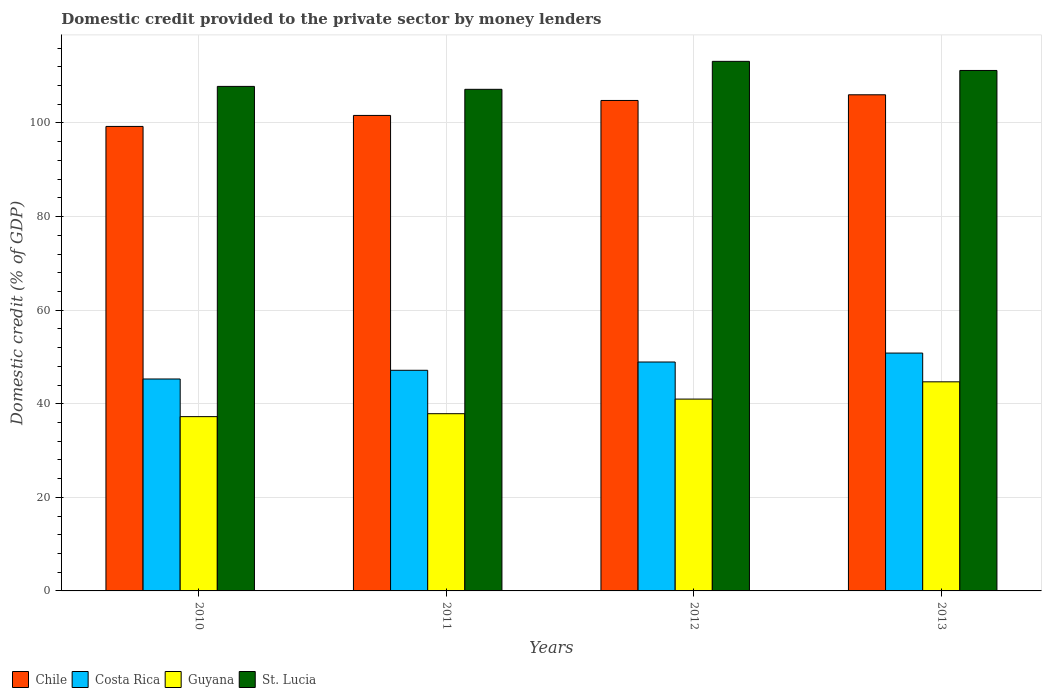How many different coloured bars are there?
Offer a very short reply. 4. How many groups of bars are there?
Ensure brevity in your answer.  4. Are the number of bars per tick equal to the number of legend labels?
Your answer should be very brief. Yes. How many bars are there on the 3rd tick from the right?
Provide a succinct answer. 4. What is the label of the 1st group of bars from the left?
Offer a terse response. 2010. What is the domestic credit provided to the private sector by money lenders in Chile in 2010?
Your answer should be very brief. 99.27. Across all years, what is the maximum domestic credit provided to the private sector by money lenders in Chile?
Provide a succinct answer. 106.03. Across all years, what is the minimum domestic credit provided to the private sector by money lenders in St. Lucia?
Your answer should be compact. 107.19. In which year was the domestic credit provided to the private sector by money lenders in Guyana minimum?
Keep it short and to the point. 2010. What is the total domestic credit provided to the private sector by money lenders in Costa Rica in the graph?
Provide a short and direct response. 192.19. What is the difference between the domestic credit provided to the private sector by money lenders in St. Lucia in 2011 and that in 2013?
Make the answer very short. -4.03. What is the difference between the domestic credit provided to the private sector by money lenders in Costa Rica in 2011 and the domestic credit provided to the private sector by money lenders in Guyana in 2010?
Provide a succinct answer. 9.9. What is the average domestic credit provided to the private sector by money lenders in Costa Rica per year?
Provide a short and direct response. 48.05. In the year 2012, what is the difference between the domestic credit provided to the private sector by money lenders in Costa Rica and domestic credit provided to the private sector by money lenders in Guyana?
Offer a very short reply. 7.92. What is the ratio of the domestic credit provided to the private sector by money lenders in Chile in 2011 to that in 2012?
Offer a very short reply. 0.97. Is the domestic credit provided to the private sector by money lenders in Guyana in 2010 less than that in 2011?
Ensure brevity in your answer.  Yes. Is the difference between the domestic credit provided to the private sector by money lenders in Costa Rica in 2010 and 2013 greater than the difference between the domestic credit provided to the private sector by money lenders in Guyana in 2010 and 2013?
Your answer should be very brief. Yes. What is the difference between the highest and the second highest domestic credit provided to the private sector by money lenders in Costa Rica?
Give a very brief answer. 1.91. What is the difference between the highest and the lowest domestic credit provided to the private sector by money lenders in Guyana?
Your answer should be very brief. 7.44. In how many years, is the domestic credit provided to the private sector by money lenders in Chile greater than the average domestic credit provided to the private sector by money lenders in Chile taken over all years?
Your answer should be compact. 2. What does the 4th bar from the left in 2010 represents?
Offer a very short reply. St. Lucia. What does the 2nd bar from the right in 2010 represents?
Your answer should be very brief. Guyana. How many bars are there?
Provide a succinct answer. 16. Are all the bars in the graph horizontal?
Provide a short and direct response. No. How many years are there in the graph?
Offer a terse response. 4. Does the graph contain grids?
Offer a terse response. Yes. How many legend labels are there?
Your answer should be very brief. 4. How are the legend labels stacked?
Your answer should be compact. Horizontal. What is the title of the graph?
Ensure brevity in your answer.  Domestic credit provided to the private sector by money lenders. What is the label or title of the X-axis?
Ensure brevity in your answer.  Years. What is the label or title of the Y-axis?
Your answer should be very brief. Domestic credit (% of GDP). What is the Domestic credit (% of GDP) of Chile in 2010?
Ensure brevity in your answer.  99.27. What is the Domestic credit (% of GDP) of Costa Rica in 2010?
Make the answer very short. 45.29. What is the Domestic credit (% of GDP) of Guyana in 2010?
Provide a short and direct response. 37.25. What is the Domestic credit (% of GDP) in St. Lucia in 2010?
Your answer should be compact. 107.82. What is the Domestic credit (% of GDP) in Chile in 2011?
Give a very brief answer. 101.62. What is the Domestic credit (% of GDP) of Costa Rica in 2011?
Keep it short and to the point. 47.15. What is the Domestic credit (% of GDP) of Guyana in 2011?
Offer a terse response. 37.88. What is the Domestic credit (% of GDP) in St. Lucia in 2011?
Your response must be concise. 107.19. What is the Domestic credit (% of GDP) of Chile in 2012?
Provide a succinct answer. 104.82. What is the Domestic credit (% of GDP) of Costa Rica in 2012?
Keep it short and to the point. 48.92. What is the Domestic credit (% of GDP) of Guyana in 2012?
Give a very brief answer. 41. What is the Domestic credit (% of GDP) of St. Lucia in 2012?
Your answer should be compact. 113.17. What is the Domestic credit (% of GDP) in Chile in 2013?
Keep it short and to the point. 106.03. What is the Domestic credit (% of GDP) in Costa Rica in 2013?
Ensure brevity in your answer.  50.83. What is the Domestic credit (% of GDP) of Guyana in 2013?
Offer a terse response. 44.69. What is the Domestic credit (% of GDP) of St. Lucia in 2013?
Offer a terse response. 111.23. Across all years, what is the maximum Domestic credit (% of GDP) of Chile?
Ensure brevity in your answer.  106.03. Across all years, what is the maximum Domestic credit (% of GDP) of Costa Rica?
Offer a terse response. 50.83. Across all years, what is the maximum Domestic credit (% of GDP) of Guyana?
Make the answer very short. 44.69. Across all years, what is the maximum Domestic credit (% of GDP) in St. Lucia?
Offer a very short reply. 113.17. Across all years, what is the minimum Domestic credit (% of GDP) of Chile?
Give a very brief answer. 99.27. Across all years, what is the minimum Domestic credit (% of GDP) in Costa Rica?
Ensure brevity in your answer.  45.29. Across all years, what is the minimum Domestic credit (% of GDP) of Guyana?
Keep it short and to the point. 37.25. Across all years, what is the minimum Domestic credit (% of GDP) of St. Lucia?
Ensure brevity in your answer.  107.19. What is the total Domestic credit (% of GDP) in Chile in the graph?
Provide a succinct answer. 411.73. What is the total Domestic credit (% of GDP) of Costa Rica in the graph?
Keep it short and to the point. 192.19. What is the total Domestic credit (% of GDP) of Guyana in the graph?
Your answer should be compact. 160.81. What is the total Domestic credit (% of GDP) of St. Lucia in the graph?
Ensure brevity in your answer.  439.41. What is the difference between the Domestic credit (% of GDP) in Chile in 2010 and that in 2011?
Give a very brief answer. -2.35. What is the difference between the Domestic credit (% of GDP) in Costa Rica in 2010 and that in 2011?
Offer a very short reply. -1.86. What is the difference between the Domestic credit (% of GDP) of Guyana in 2010 and that in 2011?
Ensure brevity in your answer.  -0.63. What is the difference between the Domestic credit (% of GDP) of St. Lucia in 2010 and that in 2011?
Offer a terse response. 0.62. What is the difference between the Domestic credit (% of GDP) in Chile in 2010 and that in 2012?
Keep it short and to the point. -5.55. What is the difference between the Domestic credit (% of GDP) of Costa Rica in 2010 and that in 2012?
Provide a succinct answer. -3.63. What is the difference between the Domestic credit (% of GDP) of Guyana in 2010 and that in 2012?
Your answer should be compact. -3.75. What is the difference between the Domestic credit (% of GDP) of St. Lucia in 2010 and that in 2012?
Your answer should be very brief. -5.35. What is the difference between the Domestic credit (% of GDP) of Chile in 2010 and that in 2013?
Give a very brief answer. -6.76. What is the difference between the Domestic credit (% of GDP) of Costa Rica in 2010 and that in 2013?
Your answer should be compact. -5.54. What is the difference between the Domestic credit (% of GDP) in Guyana in 2010 and that in 2013?
Your response must be concise. -7.44. What is the difference between the Domestic credit (% of GDP) in St. Lucia in 2010 and that in 2013?
Offer a terse response. -3.41. What is the difference between the Domestic credit (% of GDP) of Chile in 2011 and that in 2012?
Ensure brevity in your answer.  -3.2. What is the difference between the Domestic credit (% of GDP) of Costa Rica in 2011 and that in 2012?
Offer a terse response. -1.77. What is the difference between the Domestic credit (% of GDP) of Guyana in 2011 and that in 2012?
Keep it short and to the point. -3.12. What is the difference between the Domestic credit (% of GDP) of St. Lucia in 2011 and that in 2012?
Ensure brevity in your answer.  -5.98. What is the difference between the Domestic credit (% of GDP) of Chile in 2011 and that in 2013?
Make the answer very short. -4.41. What is the difference between the Domestic credit (% of GDP) of Costa Rica in 2011 and that in 2013?
Provide a short and direct response. -3.68. What is the difference between the Domestic credit (% of GDP) in Guyana in 2011 and that in 2013?
Offer a terse response. -6.81. What is the difference between the Domestic credit (% of GDP) in St. Lucia in 2011 and that in 2013?
Provide a short and direct response. -4.03. What is the difference between the Domestic credit (% of GDP) in Chile in 2012 and that in 2013?
Your response must be concise. -1.21. What is the difference between the Domestic credit (% of GDP) in Costa Rica in 2012 and that in 2013?
Provide a succinct answer. -1.91. What is the difference between the Domestic credit (% of GDP) in Guyana in 2012 and that in 2013?
Offer a very short reply. -3.69. What is the difference between the Domestic credit (% of GDP) in St. Lucia in 2012 and that in 2013?
Make the answer very short. 1.95. What is the difference between the Domestic credit (% of GDP) of Chile in 2010 and the Domestic credit (% of GDP) of Costa Rica in 2011?
Your response must be concise. 52.12. What is the difference between the Domestic credit (% of GDP) in Chile in 2010 and the Domestic credit (% of GDP) in Guyana in 2011?
Offer a very short reply. 61.39. What is the difference between the Domestic credit (% of GDP) in Chile in 2010 and the Domestic credit (% of GDP) in St. Lucia in 2011?
Your answer should be compact. -7.93. What is the difference between the Domestic credit (% of GDP) in Costa Rica in 2010 and the Domestic credit (% of GDP) in Guyana in 2011?
Provide a succinct answer. 7.42. What is the difference between the Domestic credit (% of GDP) in Costa Rica in 2010 and the Domestic credit (% of GDP) in St. Lucia in 2011?
Offer a terse response. -61.9. What is the difference between the Domestic credit (% of GDP) in Guyana in 2010 and the Domestic credit (% of GDP) in St. Lucia in 2011?
Your response must be concise. -69.95. What is the difference between the Domestic credit (% of GDP) of Chile in 2010 and the Domestic credit (% of GDP) of Costa Rica in 2012?
Ensure brevity in your answer.  50.35. What is the difference between the Domestic credit (% of GDP) of Chile in 2010 and the Domestic credit (% of GDP) of Guyana in 2012?
Make the answer very short. 58.27. What is the difference between the Domestic credit (% of GDP) in Chile in 2010 and the Domestic credit (% of GDP) in St. Lucia in 2012?
Offer a very short reply. -13.91. What is the difference between the Domestic credit (% of GDP) in Costa Rica in 2010 and the Domestic credit (% of GDP) in Guyana in 2012?
Your answer should be compact. 4.3. What is the difference between the Domestic credit (% of GDP) in Costa Rica in 2010 and the Domestic credit (% of GDP) in St. Lucia in 2012?
Provide a short and direct response. -67.88. What is the difference between the Domestic credit (% of GDP) of Guyana in 2010 and the Domestic credit (% of GDP) of St. Lucia in 2012?
Ensure brevity in your answer.  -75.93. What is the difference between the Domestic credit (% of GDP) of Chile in 2010 and the Domestic credit (% of GDP) of Costa Rica in 2013?
Your answer should be compact. 48.44. What is the difference between the Domestic credit (% of GDP) in Chile in 2010 and the Domestic credit (% of GDP) in Guyana in 2013?
Give a very brief answer. 54.58. What is the difference between the Domestic credit (% of GDP) of Chile in 2010 and the Domestic credit (% of GDP) of St. Lucia in 2013?
Your answer should be very brief. -11.96. What is the difference between the Domestic credit (% of GDP) in Costa Rica in 2010 and the Domestic credit (% of GDP) in Guyana in 2013?
Your answer should be compact. 0.6. What is the difference between the Domestic credit (% of GDP) in Costa Rica in 2010 and the Domestic credit (% of GDP) in St. Lucia in 2013?
Make the answer very short. -65.94. What is the difference between the Domestic credit (% of GDP) of Guyana in 2010 and the Domestic credit (% of GDP) of St. Lucia in 2013?
Provide a short and direct response. -73.98. What is the difference between the Domestic credit (% of GDP) in Chile in 2011 and the Domestic credit (% of GDP) in Costa Rica in 2012?
Offer a very short reply. 52.7. What is the difference between the Domestic credit (% of GDP) in Chile in 2011 and the Domestic credit (% of GDP) in Guyana in 2012?
Ensure brevity in your answer.  60.62. What is the difference between the Domestic credit (% of GDP) in Chile in 2011 and the Domestic credit (% of GDP) in St. Lucia in 2012?
Ensure brevity in your answer.  -11.56. What is the difference between the Domestic credit (% of GDP) in Costa Rica in 2011 and the Domestic credit (% of GDP) in Guyana in 2012?
Provide a short and direct response. 6.15. What is the difference between the Domestic credit (% of GDP) of Costa Rica in 2011 and the Domestic credit (% of GDP) of St. Lucia in 2012?
Keep it short and to the point. -66.02. What is the difference between the Domestic credit (% of GDP) in Guyana in 2011 and the Domestic credit (% of GDP) in St. Lucia in 2012?
Provide a succinct answer. -75.3. What is the difference between the Domestic credit (% of GDP) of Chile in 2011 and the Domestic credit (% of GDP) of Costa Rica in 2013?
Offer a terse response. 50.79. What is the difference between the Domestic credit (% of GDP) in Chile in 2011 and the Domestic credit (% of GDP) in Guyana in 2013?
Your answer should be compact. 56.93. What is the difference between the Domestic credit (% of GDP) of Chile in 2011 and the Domestic credit (% of GDP) of St. Lucia in 2013?
Make the answer very short. -9.61. What is the difference between the Domestic credit (% of GDP) of Costa Rica in 2011 and the Domestic credit (% of GDP) of Guyana in 2013?
Keep it short and to the point. 2.46. What is the difference between the Domestic credit (% of GDP) in Costa Rica in 2011 and the Domestic credit (% of GDP) in St. Lucia in 2013?
Provide a short and direct response. -64.08. What is the difference between the Domestic credit (% of GDP) of Guyana in 2011 and the Domestic credit (% of GDP) of St. Lucia in 2013?
Your answer should be very brief. -73.35. What is the difference between the Domestic credit (% of GDP) of Chile in 2012 and the Domestic credit (% of GDP) of Costa Rica in 2013?
Provide a succinct answer. 53.99. What is the difference between the Domestic credit (% of GDP) of Chile in 2012 and the Domestic credit (% of GDP) of Guyana in 2013?
Offer a terse response. 60.13. What is the difference between the Domestic credit (% of GDP) in Chile in 2012 and the Domestic credit (% of GDP) in St. Lucia in 2013?
Keep it short and to the point. -6.41. What is the difference between the Domestic credit (% of GDP) in Costa Rica in 2012 and the Domestic credit (% of GDP) in Guyana in 2013?
Provide a succinct answer. 4.23. What is the difference between the Domestic credit (% of GDP) in Costa Rica in 2012 and the Domestic credit (% of GDP) in St. Lucia in 2013?
Your answer should be compact. -62.31. What is the difference between the Domestic credit (% of GDP) in Guyana in 2012 and the Domestic credit (% of GDP) in St. Lucia in 2013?
Your response must be concise. -70.23. What is the average Domestic credit (% of GDP) in Chile per year?
Your answer should be compact. 102.93. What is the average Domestic credit (% of GDP) in Costa Rica per year?
Your answer should be compact. 48.05. What is the average Domestic credit (% of GDP) in Guyana per year?
Keep it short and to the point. 40.2. What is the average Domestic credit (% of GDP) in St. Lucia per year?
Give a very brief answer. 109.85. In the year 2010, what is the difference between the Domestic credit (% of GDP) of Chile and Domestic credit (% of GDP) of Costa Rica?
Make the answer very short. 53.97. In the year 2010, what is the difference between the Domestic credit (% of GDP) of Chile and Domestic credit (% of GDP) of Guyana?
Offer a very short reply. 62.02. In the year 2010, what is the difference between the Domestic credit (% of GDP) of Chile and Domestic credit (% of GDP) of St. Lucia?
Offer a very short reply. -8.55. In the year 2010, what is the difference between the Domestic credit (% of GDP) in Costa Rica and Domestic credit (% of GDP) in Guyana?
Your answer should be compact. 8.04. In the year 2010, what is the difference between the Domestic credit (% of GDP) in Costa Rica and Domestic credit (% of GDP) in St. Lucia?
Offer a terse response. -62.53. In the year 2010, what is the difference between the Domestic credit (% of GDP) in Guyana and Domestic credit (% of GDP) in St. Lucia?
Keep it short and to the point. -70.57. In the year 2011, what is the difference between the Domestic credit (% of GDP) in Chile and Domestic credit (% of GDP) in Costa Rica?
Provide a short and direct response. 54.47. In the year 2011, what is the difference between the Domestic credit (% of GDP) in Chile and Domestic credit (% of GDP) in Guyana?
Give a very brief answer. 63.74. In the year 2011, what is the difference between the Domestic credit (% of GDP) in Chile and Domestic credit (% of GDP) in St. Lucia?
Offer a terse response. -5.58. In the year 2011, what is the difference between the Domestic credit (% of GDP) of Costa Rica and Domestic credit (% of GDP) of Guyana?
Offer a terse response. 9.27. In the year 2011, what is the difference between the Domestic credit (% of GDP) of Costa Rica and Domestic credit (% of GDP) of St. Lucia?
Your answer should be compact. -60.04. In the year 2011, what is the difference between the Domestic credit (% of GDP) of Guyana and Domestic credit (% of GDP) of St. Lucia?
Your answer should be compact. -69.32. In the year 2012, what is the difference between the Domestic credit (% of GDP) of Chile and Domestic credit (% of GDP) of Costa Rica?
Ensure brevity in your answer.  55.9. In the year 2012, what is the difference between the Domestic credit (% of GDP) of Chile and Domestic credit (% of GDP) of Guyana?
Give a very brief answer. 63.82. In the year 2012, what is the difference between the Domestic credit (% of GDP) of Chile and Domestic credit (% of GDP) of St. Lucia?
Your answer should be compact. -8.36. In the year 2012, what is the difference between the Domestic credit (% of GDP) of Costa Rica and Domestic credit (% of GDP) of Guyana?
Offer a very short reply. 7.92. In the year 2012, what is the difference between the Domestic credit (% of GDP) of Costa Rica and Domestic credit (% of GDP) of St. Lucia?
Give a very brief answer. -64.25. In the year 2012, what is the difference between the Domestic credit (% of GDP) in Guyana and Domestic credit (% of GDP) in St. Lucia?
Ensure brevity in your answer.  -72.18. In the year 2013, what is the difference between the Domestic credit (% of GDP) of Chile and Domestic credit (% of GDP) of Costa Rica?
Make the answer very short. 55.2. In the year 2013, what is the difference between the Domestic credit (% of GDP) in Chile and Domestic credit (% of GDP) in Guyana?
Give a very brief answer. 61.34. In the year 2013, what is the difference between the Domestic credit (% of GDP) in Chile and Domestic credit (% of GDP) in St. Lucia?
Your response must be concise. -5.2. In the year 2013, what is the difference between the Domestic credit (% of GDP) in Costa Rica and Domestic credit (% of GDP) in Guyana?
Provide a succinct answer. 6.14. In the year 2013, what is the difference between the Domestic credit (% of GDP) in Costa Rica and Domestic credit (% of GDP) in St. Lucia?
Ensure brevity in your answer.  -60.4. In the year 2013, what is the difference between the Domestic credit (% of GDP) of Guyana and Domestic credit (% of GDP) of St. Lucia?
Ensure brevity in your answer.  -66.54. What is the ratio of the Domestic credit (% of GDP) in Chile in 2010 to that in 2011?
Give a very brief answer. 0.98. What is the ratio of the Domestic credit (% of GDP) in Costa Rica in 2010 to that in 2011?
Make the answer very short. 0.96. What is the ratio of the Domestic credit (% of GDP) in Guyana in 2010 to that in 2011?
Ensure brevity in your answer.  0.98. What is the ratio of the Domestic credit (% of GDP) in St. Lucia in 2010 to that in 2011?
Offer a very short reply. 1.01. What is the ratio of the Domestic credit (% of GDP) in Chile in 2010 to that in 2012?
Ensure brevity in your answer.  0.95. What is the ratio of the Domestic credit (% of GDP) of Costa Rica in 2010 to that in 2012?
Ensure brevity in your answer.  0.93. What is the ratio of the Domestic credit (% of GDP) of Guyana in 2010 to that in 2012?
Ensure brevity in your answer.  0.91. What is the ratio of the Domestic credit (% of GDP) in St. Lucia in 2010 to that in 2012?
Your answer should be compact. 0.95. What is the ratio of the Domestic credit (% of GDP) of Chile in 2010 to that in 2013?
Keep it short and to the point. 0.94. What is the ratio of the Domestic credit (% of GDP) in Costa Rica in 2010 to that in 2013?
Your response must be concise. 0.89. What is the ratio of the Domestic credit (% of GDP) of Guyana in 2010 to that in 2013?
Keep it short and to the point. 0.83. What is the ratio of the Domestic credit (% of GDP) in St. Lucia in 2010 to that in 2013?
Your answer should be very brief. 0.97. What is the ratio of the Domestic credit (% of GDP) of Chile in 2011 to that in 2012?
Provide a succinct answer. 0.97. What is the ratio of the Domestic credit (% of GDP) of Costa Rica in 2011 to that in 2012?
Keep it short and to the point. 0.96. What is the ratio of the Domestic credit (% of GDP) of Guyana in 2011 to that in 2012?
Offer a terse response. 0.92. What is the ratio of the Domestic credit (% of GDP) of St. Lucia in 2011 to that in 2012?
Keep it short and to the point. 0.95. What is the ratio of the Domestic credit (% of GDP) in Chile in 2011 to that in 2013?
Make the answer very short. 0.96. What is the ratio of the Domestic credit (% of GDP) in Costa Rica in 2011 to that in 2013?
Ensure brevity in your answer.  0.93. What is the ratio of the Domestic credit (% of GDP) of Guyana in 2011 to that in 2013?
Keep it short and to the point. 0.85. What is the ratio of the Domestic credit (% of GDP) in St. Lucia in 2011 to that in 2013?
Your answer should be compact. 0.96. What is the ratio of the Domestic credit (% of GDP) in Costa Rica in 2012 to that in 2013?
Offer a terse response. 0.96. What is the ratio of the Domestic credit (% of GDP) in Guyana in 2012 to that in 2013?
Provide a succinct answer. 0.92. What is the ratio of the Domestic credit (% of GDP) of St. Lucia in 2012 to that in 2013?
Make the answer very short. 1.02. What is the difference between the highest and the second highest Domestic credit (% of GDP) in Chile?
Offer a terse response. 1.21. What is the difference between the highest and the second highest Domestic credit (% of GDP) of Costa Rica?
Provide a short and direct response. 1.91. What is the difference between the highest and the second highest Domestic credit (% of GDP) in Guyana?
Ensure brevity in your answer.  3.69. What is the difference between the highest and the second highest Domestic credit (% of GDP) of St. Lucia?
Provide a short and direct response. 1.95. What is the difference between the highest and the lowest Domestic credit (% of GDP) of Chile?
Provide a short and direct response. 6.76. What is the difference between the highest and the lowest Domestic credit (% of GDP) in Costa Rica?
Offer a very short reply. 5.54. What is the difference between the highest and the lowest Domestic credit (% of GDP) in Guyana?
Your answer should be very brief. 7.44. What is the difference between the highest and the lowest Domestic credit (% of GDP) in St. Lucia?
Provide a short and direct response. 5.98. 